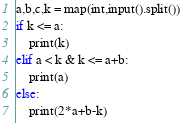<code> <loc_0><loc_0><loc_500><loc_500><_Python_>a,b,c,k = map(int,input().split())
if k <= a:
    print(k)
elif a < k & k <= a+b:
    print(a)
else:
    print(2*a+b-k)</code> 